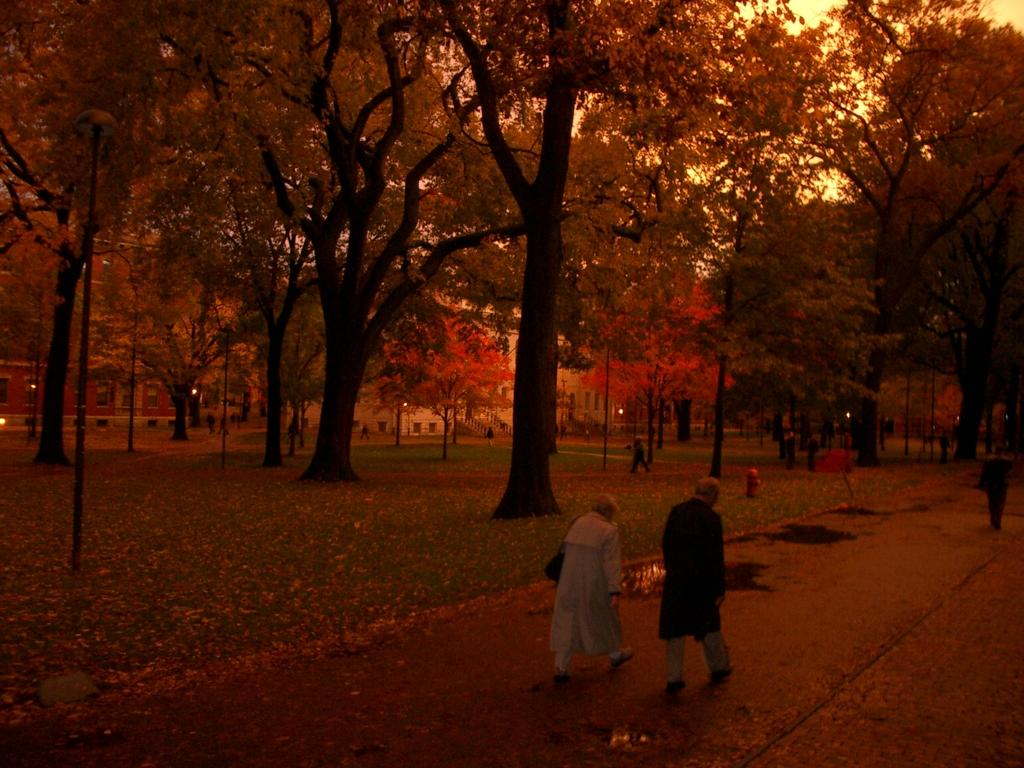What are the people in the image doing? The people in the image are walking on the road. What is the condition of the road in the image? The road has muddy water on it. What is the purpose of the object visible in the image? The fire hydrant is visible in the image, which is used for firefighting. What type of vegetation is present in the image? There is grass and trees in the image. What structures can be seen in the background of the image? Houses are visible in the background of the image. What is causing the people in the image to have sore throats? There is no information about sore throats in the image. How many teeth can be seen in the mouth of the person walking on the road? There is no person's mouth visible in the image, so it is not possible to determine the number of teeth. 